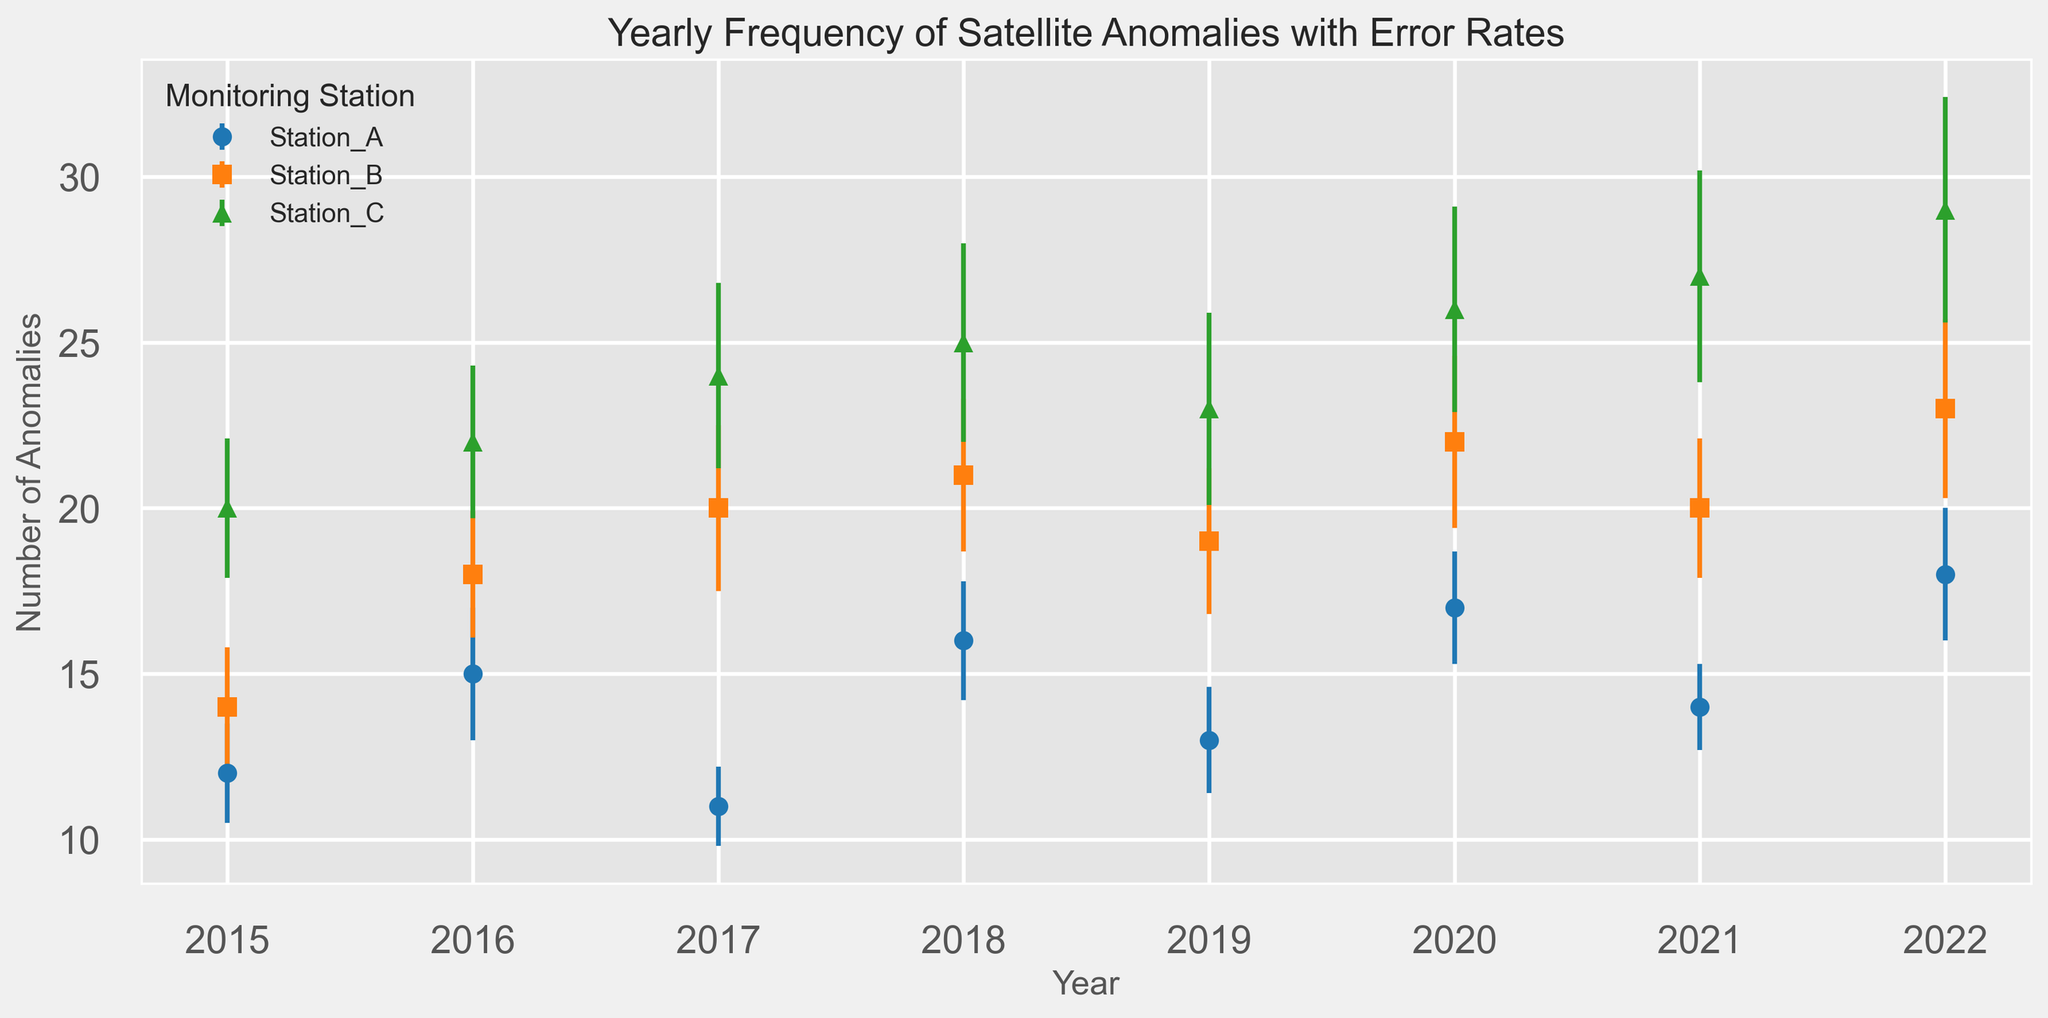What monitoring station had the highest number of anomalies in 2020? To determine the station with the highest anomalies in 2020, we look at the plotted points for that year and identify the station with the maximum anomaly value. Station_C has 26 anomalies, which is the highest among the stations for 2020.
Answer: Station_C Which station showed the least variation in anomalies over the displayed years? To find the station with the least variation, we examine the error bars' lengths for each station over the years. Station_A consistently has smaller error bars compared to Station_B and Station_C, indicating less variation.
Answer: Station_A What is the sum of anomalies reported by Station_B in 2017 and 2018? Add the anomaly counts for Station_B in 2017 and 2018. For 2017, Station_B reported 20 anomalies, and for 2018, it reported 21 anomalies. Therefore, the sum is 20 + 21 = 41.
Answer: 41 Between 2015 and 2022, which year showed the largest increase in anomalies for Station_C? Compare the year-to-year changes in anomalies for Station_C. The largest increase is between 2016 (22 anomalies) and 2017 (24 anomalies), showing an increase of 2 anomalies.
Answer: 2017 How does the error rate for Station_A in 2022 compare to its error rate in 2015? Look at the length of the error bars for Station_A in 2022 and 2015. Station_A had an error rate of 2.0 in 2022 and 1.5 in 2015. Since 2.0 is greater than 1.5, the error rate in 2022 is higher.
Answer: Higher What is the average number of anomalies for Station_C over the displayed years? To find the average anomalies for Station_C, sum up the anomalies: 20 + 22 + 24 + 25 + 23 + 26 + 27 + 29 = 196, and divide by the number of years: 196 / 8 = 24.5.
Answer: 24.5 Which year had the smallest anomaly count for Station_A, and what was the count? Identify the year with the lowest point in the plot for Station_A. In 2017, Station_A reported the smallest count of 11 anomalies.
Answer: 2017, 11 If you wanted to compare trends in anomaly counts between Station_B and Station_C from 2015 to 2022, what visual element would you focus on? To compare trends, look at the lines connecting the annual anomaly counts for both stations. By examining the slope and direction of these lines, you can see how the counts change over time.
Answer: Lines connecting annual counts What is the difference in the number of anomalies between Station_A and Station_B in 2017? To find the difference, subtract the anomaly count of Station_A from Station_B for the year 2017. Station_B had 20 anomalies, and Station_A had 11 anomalies. So, the difference is 20 - 11 = 9.
Answer: 9 In which year did Station_C see a notable spike in both anomalies and error rate? Look for a significant upward jump in both the anomalies and error bars for Station_C. In 2021, Station_C reported 27 anomalies with error rates visibly higher, indicating a spike.
Answer: 2021 